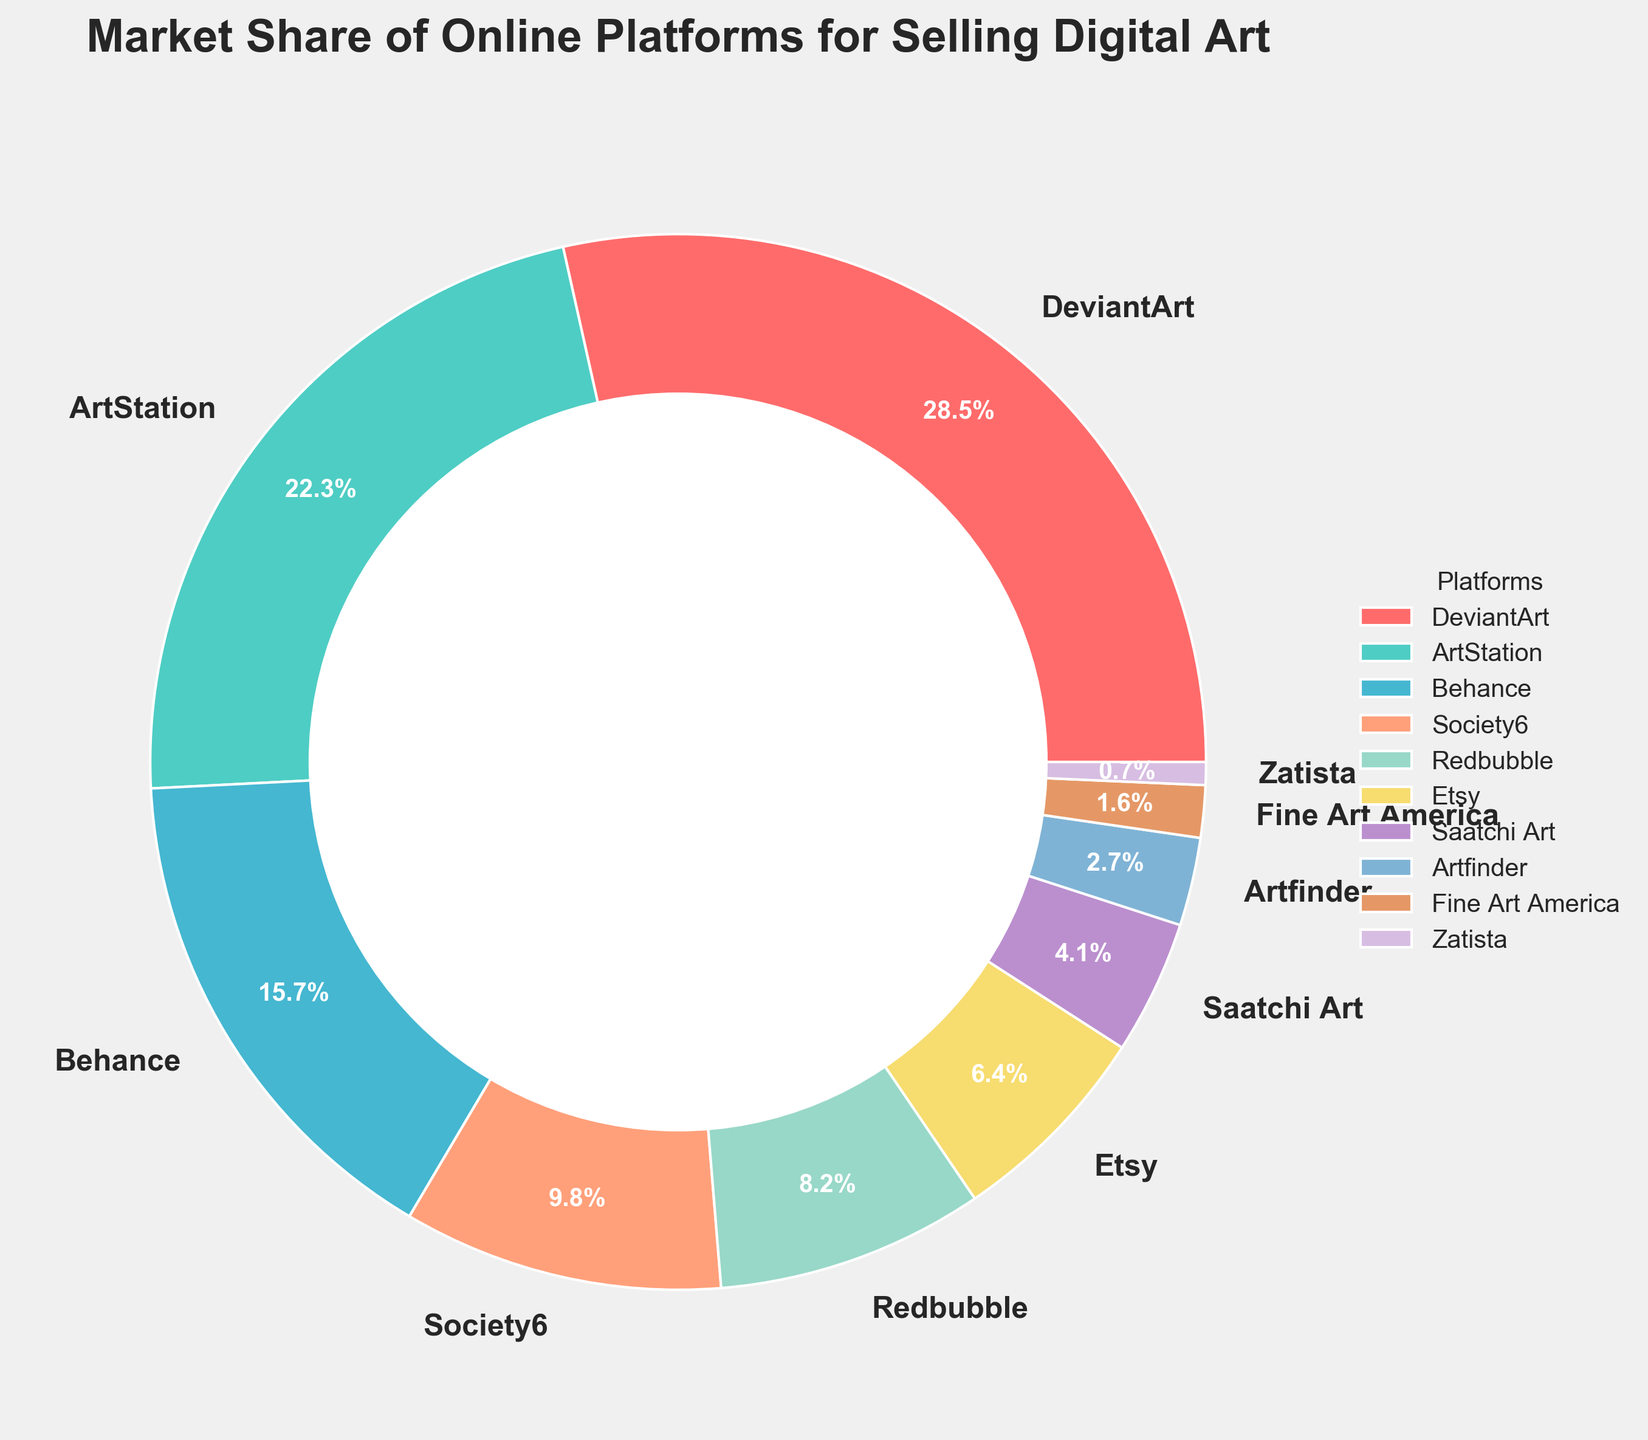Is ArtStation's market share greater than Behance's? ArtStation has a market share of 22.3%, while Behance has 15.7%. Since 22.3% is greater than 15.7%, ArtStation's market share is indeed greater than Behance's.
Answer: Yes Which platform has the smallest market share? By looking at the chart, we can observe that Zatista has the smallest market share at 0.7%.
Answer: Zatista Which two platforms combined have the highest market share? DeviantArt has 28.5% and ArtStation has 22.3%. Adding these together, we get 28.5% + 22.3% = 50.8%. Since these percentages are the largest individual shares, their combination also results in the highest market share.
Answer: DeviantArt and ArtStation What is the total market share for platforms with less than 5%? Identify platforms with less than 5%: Saatchi Art (4.1%), Artfinder (2.7%), Fine Art America (1.6%), and Zatista (0.7%). Adding these gives 4.1% + 2.7% + 1.6% + 0.7% = 9.1%.
Answer: 9.1% How much more market share does DeviantArt have compared to Redbubble? DeviantArt's market share is 28.5%, and Redbubble's is 8.2%. Subtracting these gives 28.5% - 8.2% = 20.3%.
Answer: 20.3% What is the average market share of platforms listed? Sum all market shares: 28.5 + 22.3 + 15.7 + 9.8 + 8.2 + 6.4 + 4.1 + 2.7 + 1.6 + 0.7 = 100%. There are 10 platforms, so the average is 100% / 10 = 10%.
Answer: 10% Which platform has the third-largest market share? The market shares in descending order are: DeviantArt (28.5%), ArtStation (22.3%), Behance (15.7%). So, Behance has the third-largest market share.
Answer: Behance What color represents Artfinder's segment in the pie chart? Artfinder is represented by the eighth color in the custom palette used. Referring to the list of colors, the eighth color is blue.
Answer: Blue If you combine the market shares of Behance and Society6, how does it compare to DeviantArt's market share? Behance has 15.7% and Society6 has 9.8%. Adding these together gives 15.7% + 9.8% = 25.5%. DeviantArt has 28.5%. Comparing these, 25.5% is less than 28.5%.
Answer: Less What is the median market share of all platforms? To find the median, list all market shares in order: 0.7, 1.6, 2.7, 4.1, 6.4, 8.2, 9.8, 15.7, 22.3, 28.5. With 10 numbers, the median is the average of the 5th and 6th values, which are 6.4 and 8.2. Their average is (6.4 + 8.2)/2 = 7.3.
Answer: 7.3% 